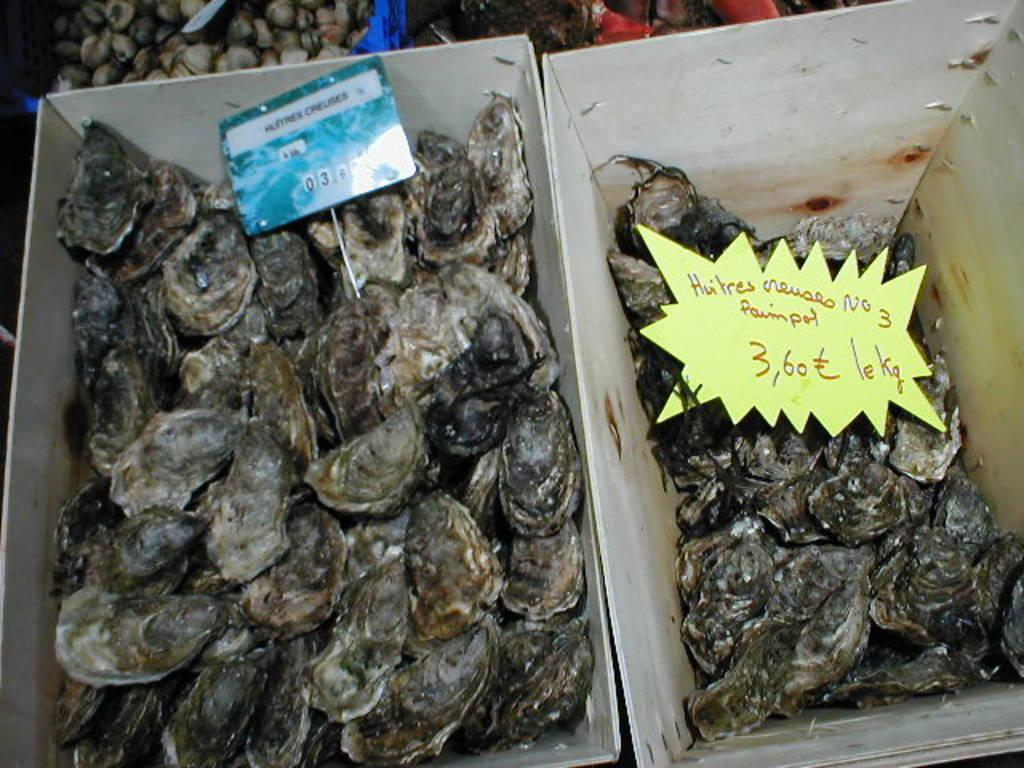What type of objects can be seen in the image? There are shells in the image. Can you describe the colors of the shells? The shells are in black, cream, and white colors. Where are the shells located? The shells are in a cardboard box. What other objects can be seen in the image? There are two boards in the image. What colors are the boards? The boards are in blue and yellow colors. What type of linen is being used to clean the shells in the image? There is no linen or cleaning activity depicted in the image; it only shows shells in a cardboard box and two boards. 